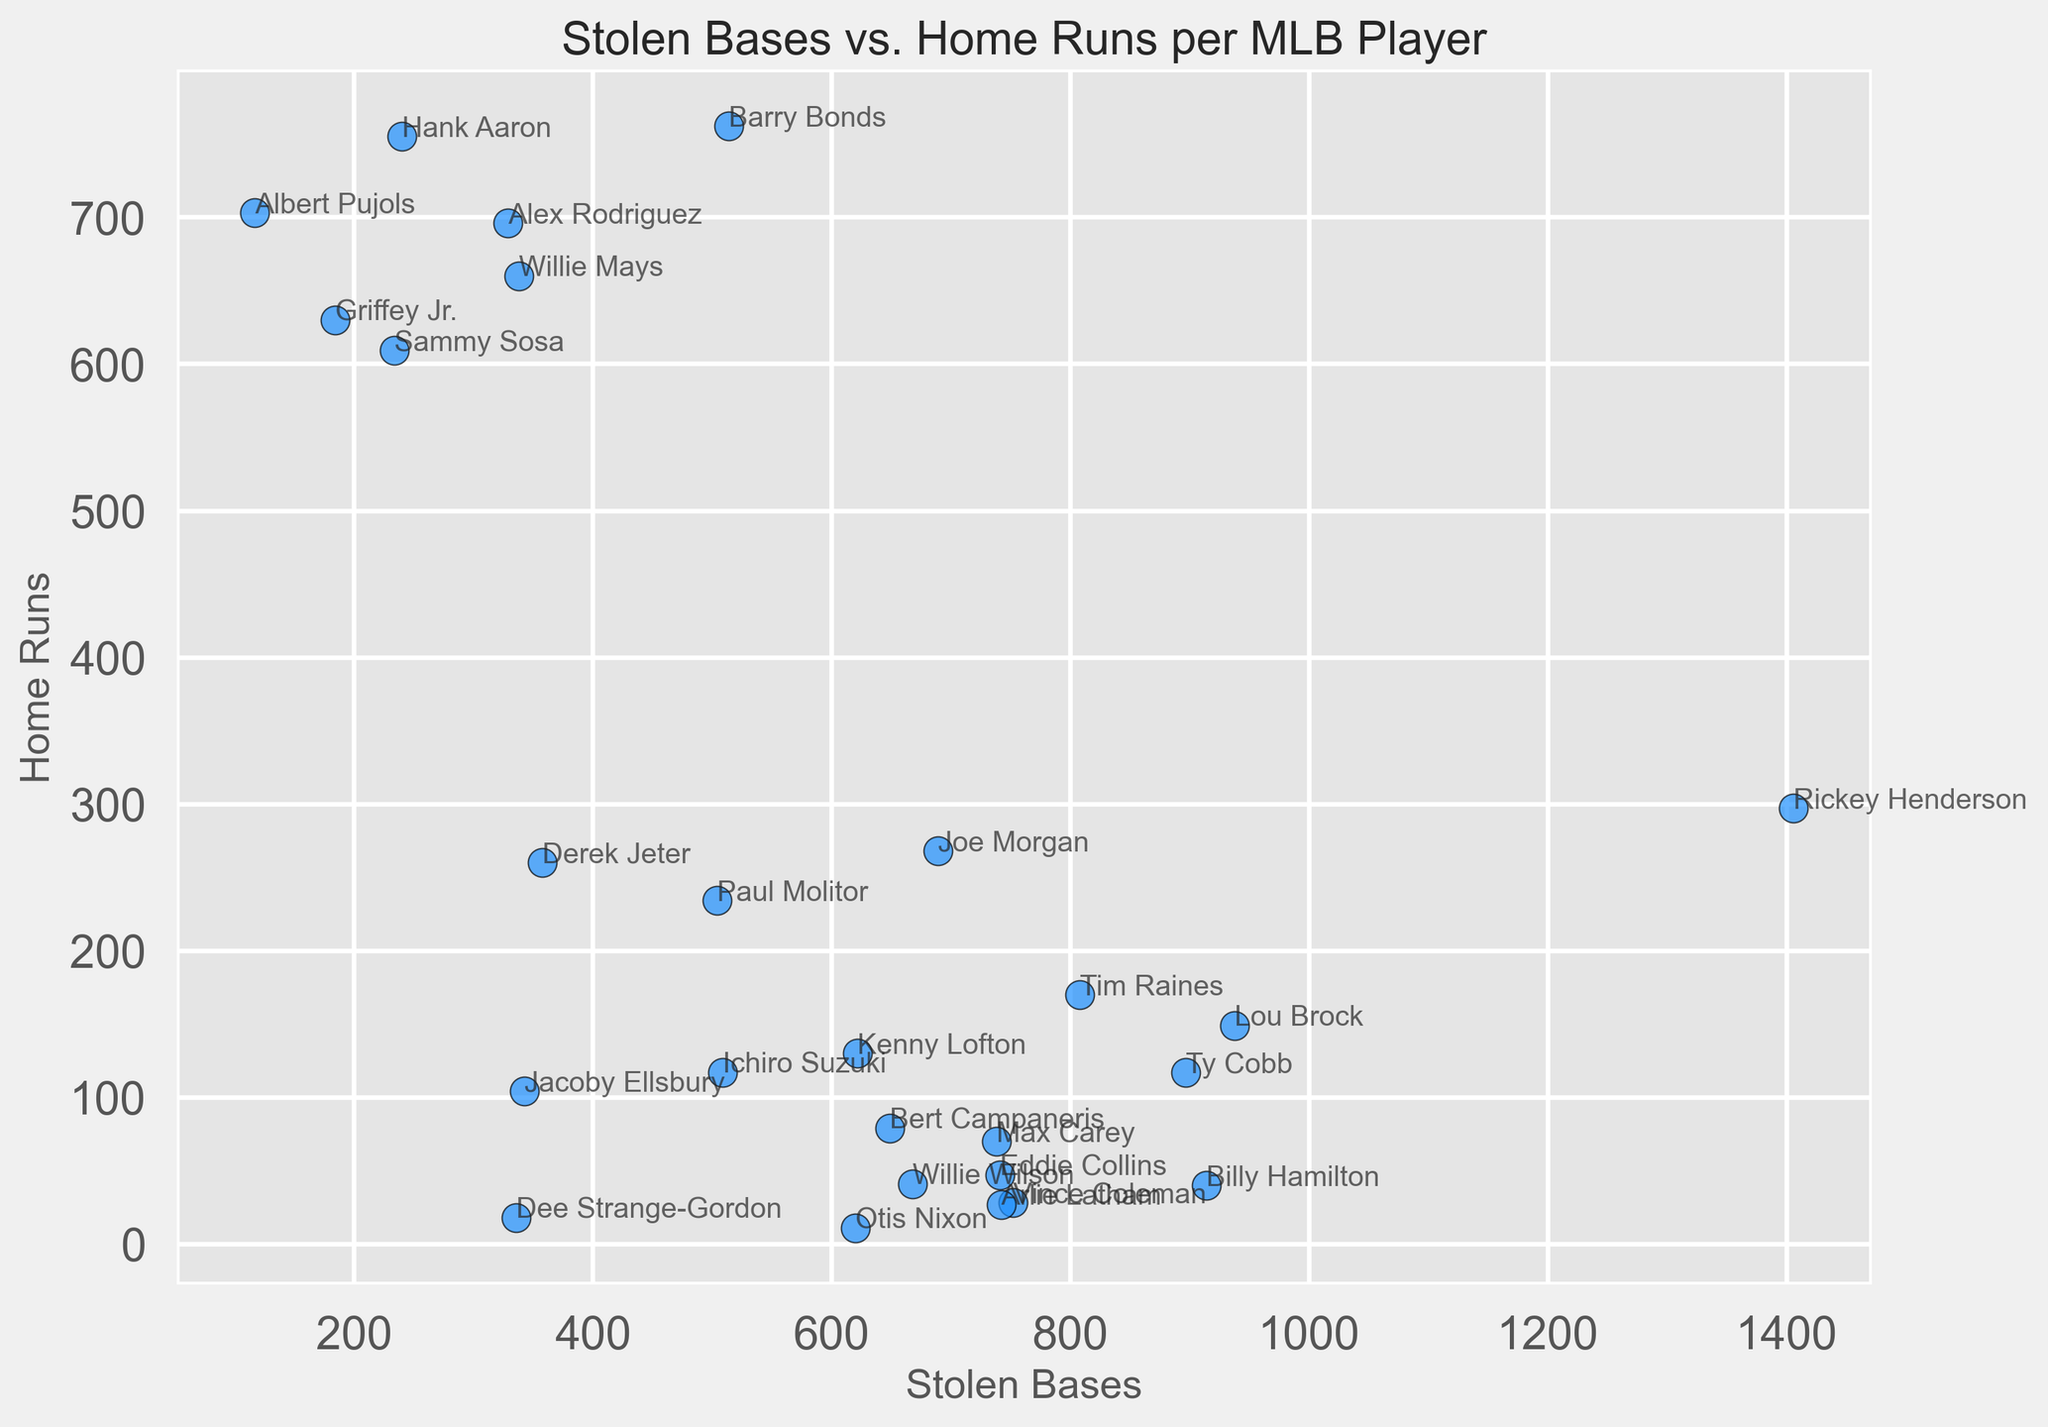Which player has the highest number of stolen bases? Looking at the scatter plot, find the point furthest to the right on the x-axis. The label next to this point will be the player with the highest number of stolen bases.
Answer: Rickey Henderson Which player has more home runs: Barry Bonds or Hank Aaron? Locate the points labeled "Barry Bonds" and "Hank Aaron" on the plot. Compare the y-coordinates (Home Runs) of these two points. Barry Bonds is higher than Hank Aaron.
Answer: Barry Bonds How many players have more than 500 stolen bases but fewer than 150 home runs? Locate the players with x-coordinates greater than 500 and y-coordinates less than 150. Count these points.
Answer: 6 What is the average number of home runs for players with at least 700 stolen bases? Identify the players with x-coordinates of 700 or higher. Sum their y-coordinates (Home Runs) and divide by the number of such players. (297 + 149 + 40 + 117 + 170 + 28 + 27) / 7
Answer: 118 Who has more stolen bases, Ichiro Suzuki or Derek Jeter? Compare the x-coordinates of the labeled points for "Ichiro Suzuki" and "Derek Jeter." Ichiro Suzuki has a higher x-coordinate.
Answer: Ichiro Suzuki Which player has the closest number of stolen bases and home runs? Compare the x-coordinates (Stolen Bases) and y-coordinates (Home Runs) for all players. Look for the smallest difference between these values.
Answer: Barry Bonds Which player with fewer than 100 stolen bases has the most home runs? Look for points with x-coordinates less than 100. Among these, identify the point with the highest y-coordinate.
Answer: Albert Pujols Is there any player with exactly 500 stolen bases? Check the scatter plot for any point on the vertical line at 500 on the x-axis.
Answer: No 